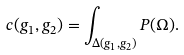<formula> <loc_0><loc_0><loc_500><loc_500>c ( g _ { 1 } , g _ { 2 } ) = \int _ { \Delta ( g _ { 1 } , g _ { 2 } ) } P ( \Omega ) .</formula> 